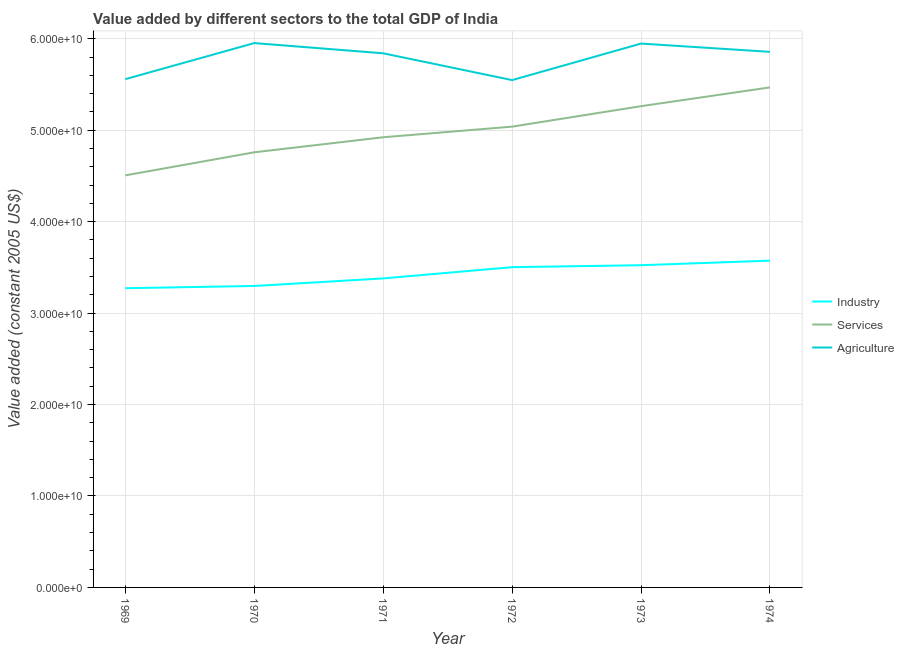Is the number of lines equal to the number of legend labels?
Offer a very short reply. Yes. What is the value added by industrial sector in 1971?
Provide a short and direct response. 3.38e+1. Across all years, what is the maximum value added by services?
Offer a terse response. 5.47e+1. Across all years, what is the minimum value added by agricultural sector?
Give a very brief answer. 5.55e+1. In which year was the value added by industrial sector minimum?
Your answer should be compact. 1969. What is the total value added by services in the graph?
Provide a short and direct response. 3.00e+11. What is the difference between the value added by agricultural sector in 1971 and that in 1972?
Provide a short and direct response. 2.93e+09. What is the difference between the value added by services in 1971 and the value added by industrial sector in 1970?
Offer a very short reply. 1.63e+1. What is the average value added by agricultural sector per year?
Your response must be concise. 5.78e+1. In the year 1971, what is the difference between the value added by agricultural sector and value added by services?
Give a very brief answer. 9.18e+09. In how many years, is the value added by services greater than 20000000000 US$?
Your response must be concise. 6. What is the ratio of the value added by industrial sector in 1969 to that in 1972?
Provide a succinct answer. 0.93. Is the difference between the value added by industrial sector in 1972 and 1974 greater than the difference between the value added by services in 1972 and 1974?
Offer a very short reply. Yes. What is the difference between the highest and the second highest value added by industrial sector?
Provide a succinct answer. 4.98e+08. What is the difference between the highest and the lowest value added by agricultural sector?
Your answer should be compact. 4.05e+09. In how many years, is the value added by agricultural sector greater than the average value added by agricultural sector taken over all years?
Make the answer very short. 4. Is the value added by industrial sector strictly less than the value added by services over the years?
Your response must be concise. Yes. How many lines are there?
Keep it short and to the point. 3. How many years are there in the graph?
Offer a terse response. 6. Are the values on the major ticks of Y-axis written in scientific E-notation?
Give a very brief answer. Yes. Does the graph contain any zero values?
Provide a succinct answer. No. How many legend labels are there?
Make the answer very short. 3. How are the legend labels stacked?
Make the answer very short. Vertical. What is the title of the graph?
Make the answer very short. Value added by different sectors to the total GDP of India. Does "Neonatal" appear as one of the legend labels in the graph?
Give a very brief answer. No. What is the label or title of the Y-axis?
Offer a terse response. Value added (constant 2005 US$). What is the Value added (constant 2005 US$) of Industry in 1969?
Your response must be concise. 3.27e+1. What is the Value added (constant 2005 US$) of Services in 1969?
Provide a short and direct response. 4.51e+1. What is the Value added (constant 2005 US$) in Agriculture in 1969?
Offer a terse response. 5.56e+1. What is the Value added (constant 2005 US$) of Industry in 1970?
Your answer should be compact. 3.30e+1. What is the Value added (constant 2005 US$) in Services in 1970?
Offer a very short reply. 4.76e+1. What is the Value added (constant 2005 US$) in Agriculture in 1970?
Offer a terse response. 5.95e+1. What is the Value added (constant 2005 US$) in Industry in 1971?
Offer a very short reply. 3.38e+1. What is the Value added (constant 2005 US$) of Services in 1971?
Provide a short and direct response. 4.92e+1. What is the Value added (constant 2005 US$) of Agriculture in 1971?
Your answer should be very brief. 5.84e+1. What is the Value added (constant 2005 US$) of Industry in 1972?
Your response must be concise. 3.50e+1. What is the Value added (constant 2005 US$) of Services in 1972?
Provide a short and direct response. 5.04e+1. What is the Value added (constant 2005 US$) in Agriculture in 1972?
Offer a terse response. 5.55e+1. What is the Value added (constant 2005 US$) in Industry in 1973?
Keep it short and to the point. 3.52e+1. What is the Value added (constant 2005 US$) in Services in 1973?
Make the answer very short. 5.26e+1. What is the Value added (constant 2005 US$) of Agriculture in 1973?
Give a very brief answer. 5.95e+1. What is the Value added (constant 2005 US$) of Industry in 1974?
Keep it short and to the point. 3.57e+1. What is the Value added (constant 2005 US$) in Services in 1974?
Your answer should be compact. 5.47e+1. What is the Value added (constant 2005 US$) of Agriculture in 1974?
Your answer should be compact. 5.86e+1. Across all years, what is the maximum Value added (constant 2005 US$) of Industry?
Provide a short and direct response. 3.57e+1. Across all years, what is the maximum Value added (constant 2005 US$) of Services?
Give a very brief answer. 5.47e+1. Across all years, what is the maximum Value added (constant 2005 US$) in Agriculture?
Give a very brief answer. 5.95e+1. Across all years, what is the minimum Value added (constant 2005 US$) of Industry?
Your answer should be compact. 3.27e+1. Across all years, what is the minimum Value added (constant 2005 US$) in Services?
Keep it short and to the point. 4.51e+1. Across all years, what is the minimum Value added (constant 2005 US$) of Agriculture?
Provide a short and direct response. 5.55e+1. What is the total Value added (constant 2005 US$) in Industry in the graph?
Your answer should be very brief. 2.06e+11. What is the total Value added (constant 2005 US$) of Services in the graph?
Offer a terse response. 3.00e+11. What is the total Value added (constant 2005 US$) of Agriculture in the graph?
Give a very brief answer. 3.47e+11. What is the difference between the Value added (constant 2005 US$) of Industry in 1969 and that in 1970?
Provide a short and direct response. -2.44e+08. What is the difference between the Value added (constant 2005 US$) in Services in 1969 and that in 1970?
Your response must be concise. -2.52e+09. What is the difference between the Value added (constant 2005 US$) of Agriculture in 1969 and that in 1970?
Make the answer very short. -3.94e+09. What is the difference between the Value added (constant 2005 US$) in Industry in 1969 and that in 1971?
Make the answer very short. -1.07e+09. What is the difference between the Value added (constant 2005 US$) in Services in 1969 and that in 1971?
Your response must be concise. -4.17e+09. What is the difference between the Value added (constant 2005 US$) in Agriculture in 1969 and that in 1971?
Your response must be concise. -2.83e+09. What is the difference between the Value added (constant 2005 US$) in Industry in 1969 and that in 1972?
Your response must be concise. -2.30e+09. What is the difference between the Value added (constant 2005 US$) of Services in 1969 and that in 1972?
Give a very brief answer. -5.33e+09. What is the difference between the Value added (constant 2005 US$) of Agriculture in 1969 and that in 1972?
Make the answer very short. 1.07e+08. What is the difference between the Value added (constant 2005 US$) of Industry in 1969 and that in 1973?
Offer a terse response. -2.52e+09. What is the difference between the Value added (constant 2005 US$) in Services in 1969 and that in 1973?
Give a very brief answer. -7.57e+09. What is the difference between the Value added (constant 2005 US$) in Agriculture in 1969 and that in 1973?
Keep it short and to the point. -3.89e+09. What is the difference between the Value added (constant 2005 US$) in Industry in 1969 and that in 1974?
Make the answer very short. -3.01e+09. What is the difference between the Value added (constant 2005 US$) of Services in 1969 and that in 1974?
Provide a short and direct response. -9.62e+09. What is the difference between the Value added (constant 2005 US$) of Agriculture in 1969 and that in 1974?
Your answer should be compact. -2.98e+09. What is the difference between the Value added (constant 2005 US$) in Industry in 1970 and that in 1971?
Give a very brief answer. -8.27e+08. What is the difference between the Value added (constant 2005 US$) of Services in 1970 and that in 1971?
Give a very brief answer. -1.64e+09. What is the difference between the Value added (constant 2005 US$) of Agriculture in 1970 and that in 1971?
Make the answer very short. 1.12e+09. What is the difference between the Value added (constant 2005 US$) in Industry in 1970 and that in 1972?
Make the answer very short. -2.06e+09. What is the difference between the Value added (constant 2005 US$) of Services in 1970 and that in 1972?
Make the answer very short. -2.81e+09. What is the difference between the Value added (constant 2005 US$) of Agriculture in 1970 and that in 1972?
Offer a very short reply. 4.05e+09. What is the difference between the Value added (constant 2005 US$) of Industry in 1970 and that in 1973?
Offer a terse response. -2.27e+09. What is the difference between the Value added (constant 2005 US$) of Services in 1970 and that in 1973?
Ensure brevity in your answer.  -5.05e+09. What is the difference between the Value added (constant 2005 US$) of Agriculture in 1970 and that in 1973?
Ensure brevity in your answer.  5.33e+07. What is the difference between the Value added (constant 2005 US$) of Industry in 1970 and that in 1974?
Keep it short and to the point. -2.77e+09. What is the difference between the Value added (constant 2005 US$) of Services in 1970 and that in 1974?
Give a very brief answer. -7.10e+09. What is the difference between the Value added (constant 2005 US$) of Agriculture in 1970 and that in 1974?
Your answer should be compact. 9.59e+08. What is the difference between the Value added (constant 2005 US$) of Industry in 1971 and that in 1972?
Provide a succinct answer. -1.23e+09. What is the difference between the Value added (constant 2005 US$) of Services in 1971 and that in 1972?
Offer a terse response. -1.16e+09. What is the difference between the Value added (constant 2005 US$) of Agriculture in 1971 and that in 1972?
Your answer should be very brief. 2.93e+09. What is the difference between the Value added (constant 2005 US$) of Industry in 1971 and that in 1973?
Ensure brevity in your answer.  -1.44e+09. What is the difference between the Value added (constant 2005 US$) of Services in 1971 and that in 1973?
Provide a short and direct response. -3.40e+09. What is the difference between the Value added (constant 2005 US$) in Agriculture in 1971 and that in 1973?
Give a very brief answer. -1.06e+09. What is the difference between the Value added (constant 2005 US$) of Industry in 1971 and that in 1974?
Provide a succinct answer. -1.94e+09. What is the difference between the Value added (constant 2005 US$) of Services in 1971 and that in 1974?
Offer a terse response. -5.46e+09. What is the difference between the Value added (constant 2005 US$) of Agriculture in 1971 and that in 1974?
Provide a short and direct response. -1.58e+08. What is the difference between the Value added (constant 2005 US$) of Industry in 1972 and that in 1973?
Your answer should be very brief. -2.15e+08. What is the difference between the Value added (constant 2005 US$) in Services in 1972 and that in 1973?
Make the answer very short. -2.24e+09. What is the difference between the Value added (constant 2005 US$) of Agriculture in 1972 and that in 1973?
Provide a short and direct response. -4.00e+09. What is the difference between the Value added (constant 2005 US$) of Industry in 1972 and that in 1974?
Offer a terse response. -7.13e+08. What is the difference between the Value added (constant 2005 US$) of Services in 1972 and that in 1974?
Provide a succinct answer. -4.29e+09. What is the difference between the Value added (constant 2005 US$) in Agriculture in 1972 and that in 1974?
Your response must be concise. -3.09e+09. What is the difference between the Value added (constant 2005 US$) in Industry in 1973 and that in 1974?
Give a very brief answer. -4.98e+08. What is the difference between the Value added (constant 2005 US$) in Services in 1973 and that in 1974?
Your answer should be very brief. -2.06e+09. What is the difference between the Value added (constant 2005 US$) in Agriculture in 1973 and that in 1974?
Your answer should be compact. 9.06e+08. What is the difference between the Value added (constant 2005 US$) in Industry in 1969 and the Value added (constant 2005 US$) in Services in 1970?
Provide a succinct answer. -1.49e+1. What is the difference between the Value added (constant 2005 US$) of Industry in 1969 and the Value added (constant 2005 US$) of Agriculture in 1970?
Ensure brevity in your answer.  -2.68e+1. What is the difference between the Value added (constant 2005 US$) of Services in 1969 and the Value added (constant 2005 US$) of Agriculture in 1970?
Your answer should be compact. -1.45e+1. What is the difference between the Value added (constant 2005 US$) of Industry in 1969 and the Value added (constant 2005 US$) of Services in 1971?
Keep it short and to the point. -1.65e+1. What is the difference between the Value added (constant 2005 US$) of Industry in 1969 and the Value added (constant 2005 US$) of Agriculture in 1971?
Make the answer very short. -2.57e+1. What is the difference between the Value added (constant 2005 US$) of Services in 1969 and the Value added (constant 2005 US$) of Agriculture in 1971?
Your response must be concise. -1.34e+1. What is the difference between the Value added (constant 2005 US$) in Industry in 1969 and the Value added (constant 2005 US$) in Services in 1972?
Your answer should be very brief. -1.77e+1. What is the difference between the Value added (constant 2005 US$) of Industry in 1969 and the Value added (constant 2005 US$) of Agriculture in 1972?
Offer a terse response. -2.28e+1. What is the difference between the Value added (constant 2005 US$) of Services in 1969 and the Value added (constant 2005 US$) of Agriculture in 1972?
Your response must be concise. -1.04e+1. What is the difference between the Value added (constant 2005 US$) in Industry in 1969 and the Value added (constant 2005 US$) in Services in 1973?
Provide a short and direct response. -1.99e+1. What is the difference between the Value added (constant 2005 US$) of Industry in 1969 and the Value added (constant 2005 US$) of Agriculture in 1973?
Keep it short and to the point. -2.68e+1. What is the difference between the Value added (constant 2005 US$) in Services in 1969 and the Value added (constant 2005 US$) in Agriculture in 1973?
Keep it short and to the point. -1.44e+1. What is the difference between the Value added (constant 2005 US$) of Industry in 1969 and the Value added (constant 2005 US$) of Services in 1974?
Offer a terse response. -2.20e+1. What is the difference between the Value added (constant 2005 US$) of Industry in 1969 and the Value added (constant 2005 US$) of Agriculture in 1974?
Provide a succinct answer. -2.59e+1. What is the difference between the Value added (constant 2005 US$) in Services in 1969 and the Value added (constant 2005 US$) in Agriculture in 1974?
Provide a succinct answer. -1.35e+1. What is the difference between the Value added (constant 2005 US$) of Industry in 1970 and the Value added (constant 2005 US$) of Services in 1971?
Give a very brief answer. -1.63e+1. What is the difference between the Value added (constant 2005 US$) in Industry in 1970 and the Value added (constant 2005 US$) in Agriculture in 1971?
Ensure brevity in your answer.  -2.54e+1. What is the difference between the Value added (constant 2005 US$) in Services in 1970 and the Value added (constant 2005 US$) in Agriculture in 1971?
Ensure brevity in your answer.  -1.08e+1. What is the difference between the Value added (constant 2005 US$) in Industry in 1970 and the Value added (constant 2005 US$) in Services in 1972?
Offer a very short reply. -1.74e+1. What is the difference between the Value added (constant 2005 US$) of Industry in 1970 and the Value added (constant 2005 US$) of Agriculture in 1972?
Your response must be concise. -2.25e+1. What is the difference between the Value added (constant 2005 US$) in Services in 1970 and the Value added (constant 2005 US$) in Agriculture in 1972?
Offer a terse response. -7.90e+09. What is the difference between the Value added (constant 2005 US$) in Industry in 1970 and the Value added (constant 2005 US$) in Services in 1973?
Your answer should be compact. -1.97e+1. What is the difference between the Value added (constant 2005 US$) in Industry in 1970 and the Value added (constant 2005 US$) in Agriculture in 1973?
Your answer should be compact. -2.65e+1. What is the difference between the Value added (constant 2005 US$) in Services in 1970 and the Value added (constant 2005 US$) in Agriculture in 1973?
Offer a very short reply. -1.19e+1. What is the difference between the Value added (constant 2005 US$) in Industry in 1970 and the Value added (constant 2005 US$) in Services in 1974?
Keep it short and to the point. -2.17e+1. What is the difference between the Value added (constant 2005 US$) of Industry in 1970 and the Value added (constant 2005 US$) of Agriculture in 1974?
Your response must be concise. -2.56e+1. What is the difference between the Value added (constant 2005 US$) in Services in 1970 and the Value added (constant 2005 US$) in Agriculture in 1974?
Keep it short and to the point. -1.10e+1. What is the difference between the Value added (constant 2005 US$) of Industry in 1971 and the Value added (constant 2005 US$) of Services in 1972?
Your answer should be very brief. -1.66e+1. What is the difference between the Value added (constant 2005 US$) in Industry in 1971 and the Value added (constant 2005 US$) in Agriculture in 1972?
Your response must be concise. -2.17e+1. What is the difference between the Value added (constant 2005 US$) of Services in 1971 and the Value added (constant 2005 US$) of Agriculture in 1972?
Offer a very short reply. -6.25e+09. What is the difference between the Value added (constant 2005 US$) of Industry in 1971 and the Value added (constant 2005 US$) of Services in 1973?
Ensure brevity in your answer.  -1.88e+1. What is the difference between the Value added (constant 2005 US$) in Industry in 1971 and the Value added (constant 2005 US$) in Agriculture in 1973?
Provide a short and direct response. -2.57e+1. What is the difference between the Value added (constant 2005 US$) in Services in 1971 and the Value added (constant 2005 US$) in Agriculture in 1973?
Ensure brevity in your answer.  -1.02e+1. What is the difference between the Value added (constant 2005 US$) of Industry in 1971 and the Value added (constant 2005 US$) of Services in 1974?
Keep it short and to the point. -2.09e+1. What is the difference between the Value added (constant 2005 US$) in Industry in 1971 and the Value added (constant 2005 US$) in Agriculture in 1974?
Ensure brevity in your answer.  -2.48e+1. What is the difference between the Value added (constant 2005 US$) in Services in 1971 and the Value added (constant 2005 US$) in Agriculture in 1974?
Make the answer very short. -9.34e+09. What is the difference between the Value added (constant 2005 US$) of Industry in 1972 and the Value added (constant 2005 US$) of Services in 1973?
Offer a terse response. -1.76e+1. What is the difference between the Value added (constant 2005 US$) of Industry in 1972 and the Value added (constant 2005 US$) of Agriculture in 1973?
Provide a succinct answer. -2.45e+1. What is the difference between the Value added (constant 2005 US$) in Services in 1972 and the Value added (constant 2005 US$) in Agriculture in 1973?
Your answer should be compact. -9.08e+09. What is the difference between the Value added (constant 2005 US$) of Industry in 1972 and the Value added (constant 2005 US$) of Services in 1974?
Your answer should be compact. -1.97e+1. What is the difference between the Value added (constant 2005 US$) of Industry in 1972 and the Value added (constant 2005 US$) of Agriculture in 1974?
Provide a succinct answer. -2.35e+1. What is the difference between the Value added (constant 2005 US$) in Services in 1972 and the Value added (constant 2005 US$) in Agriculture in 1974?
Your answer should be very brief. -8.18e+09. What is the difference between the Value added (constant 2005 US$) in Industry in 1973 and the Value added (constant 2005 US$) in Services in 1974?
Provide a short and direct response. -1.94e+1. What is the difference between the Value added (constant 2005 US$) in Industry in 1973 and the Value added (constant 2005 US$) in Agriculture in 1974?
Your response must be concise. -2.33e+1. What is the difference between the Value added (constant 2005 US$) of Services in 1973 and the Value added (constant 2005 US$) of Agriculture in 1974?
Your answer should be very brief. -5.94e+09. What is the average Value added (constant 2005 US$) in Industry per year?
Offer a very short reply. 3.43e+1. What is the average Value added (constant 2005 US$) in Services per year?
Ensure brevity in your answer.  4.99e+1. What is the average Value added (constant 2005 US$) of Agriculture per year?
Ensure brevity in your answer.  5.78e+1. In the year 1969, what is the difference between the Value added (constant 2005 US$) of Industry and Value added (constant 2005 US$) of Services?
Give a very brief answer. -1.23e+1. In the year 1969, what is the difference between the Value added (constant 2005 US$) in Industry and Value added (constant 2005 US$) in Agriculture?
Keep it short and to the point. -2.29e+1. In the year 1969, what is the difference between the Value added (constant 2005 US$) of Services and Value added (constant 2005 US$) of Agriculture?
Keep it short and to the point. -1.05e+1. In the year 1970, what is the difference between the Value added (constant 2005 US$) in Industry and Value added (constant 2005 US$) in Services?
Make the answer very short. -1.46e+1. In the year 1970, what is the difference between the Value added (constant 2005 US$) in Industry and Value added (constant 2005 US$) in Agriculture?
Make the answer very short. -2.66e+1. In the year 1970, what is the difference between the Value added (constant 2005 US$) of Services and Value added (constant 2005 US$) of Agriculture?
Offer a very short reply. -1.19e+1. In the year 1971, what is the difference between the Value added (constant 2005 US$) in Industry and Value added (constant 2005 US$) in Services?
Keep it short and to the point. -1.54e+1. In the year 1971, what is the difference between the Value added (constant 2005 US$) in Industry and Value added (constant 2005 US$) in Agriculture?
Make the answer very short. -2.46e+1. In the year 1971, what is the difference between the Value added (constant 2005 US$) of Services and Value added (constant 2005 US$) of Agriculture?
Your answer should be compact. -9.18e+09. In the year 1972, what is the difference between the Value added (constant 2005 US$) of Industry and Value added (constant 2005 US$) of Services?
Provide a succinct answer. -1.54e+1. In the year 1972, what is the difference between the Value added (constant 2005 US$) of Industry and Value added (constant 2005 US$) of Agriculture?
Provide a short and direct response. -2.05e+1. In the year 1972, what is the difference between the Value added (constant 2005 US$) of Services and Value added (constant 2005 US$) of Agriculture?
Provide a short and direct response. -5.09e+09. In the year 1973, what is the difference between the Value added (constant 2005 US$) of Industry and Value added (constant 2005 US$) of Services?
Keep it short and to the point. -1.74e+1. In the year 1973, what is the difference between the Value added (constant 2005 US$) in Industry and Value added (constant 2005 US$) in Agriculture?
Offer a very short reply. -2.42e+1. In the year 1973, what is the difference between the Value added (constant 2005 US$) of Services and Value added (constant 2005 US$) of Agriculture?
Ensure brevity in your answer.  -6.85e+09. In the year 1974, what is the difference between the Value added (constant 2005 US$) of Industry and Value added (constant 2005 US$) of Services?
Provide a short and direct response. -1.90e+1. In the year 1974, what is the difference between the Value added (constant 2005 US$) in Industry and Value added (constant 2005 US$) in Agriculture?
Offer a terse response. -2.28e+1. In the year 1974, what is the difference between the Value added (constant 2005 US$) of Services and Value added (constant 2005 US$) of Agriculture?
Your answer should be very brief. -3.89e+09. What is the ratio of the Value added (constant 2005 US$) of Industry in 1969 to that in 1970?
Offer a terse response. 0.99. What is the ratio of the Value added (constant 2005 US$) in Services in 1969 to that in 1970?
Your answer should be compact. 0.95. What is the ratio of the Value added (constant 2005 US$) in Agriculture in 1969 to that in 1970?
Give a very brief answer. 0.93. What is the ratio of the Value added (constant 2005 US$) of Industry in 1969 to that in 1971?
Offer a very short reply. 0.97. What is the ratio of the Value added (constant 2005 US$) in Services in 1969 to that in 1971?
Your answer should be compact. 0.92. What is the ratio of the Value added (constant 2005 US$) in Agriculture in 1969 to that in 1971?
Your answer should be very brief. 0.95. What is the ratio of the Value added (constant 2005 US$) of Industry in 1969 to that in 1972?
Make the answer very short. 0.93. What is the ratio of the Value added (constant 2005 US$) in Services in 1969 to that in 1972?
Keep it short and to the point. 0.89. What is the ratio of the Value added (constant 2005 US$) of Services in 1969 to that in 1973?
Provide a short and direct response. 0.86. What is the ratio of the Value added (constant 2005 US$) of Agriculture in 1969 to that in 1973?
Offer a terse response. 0.93. What is the ratio of the Value added (constant 2005 US$) of Industry in 1969 to that in 1974?
Offer a very short reply. 0.92. What is the ratio of the Value added (constant 2005 US$) in Services in 1969 to that in 1974?
Provide a short and direct response. 0.82. What is the ratio of the Value added (constant 2005 US$) in Agriculture in 1969 to that in 1974?
Keep it short and to the point. 0.95. What is the ratio of the Value added (constant 2005 US$) in Industry in 1970 to that in 1971?
Your response must be concise. 0.98. What is the ratio of the Value added (constant 2005 US$) of Services in 1970 to that in 1971?
Your answer should be very brief. 0.97. What is the ratio of the Value added (constant 2005 US$) of Agriculture in 1970 to that in 1971?
Offer a terse response. 1.02. What is the ratio of the Value added (constant 2005 US$) of Industry in 1970 to that in 1972?
Your answer should be very brief. 0.94. What is the ratio of the Value added (constant 2005 US$) of Services in 1970 to that in 1972?
Your response must be concise. 0.94. What is the ratio of the Value added (constant 2005 US$) of Agriculture in 1970 to that in 1972?
Your response must be concise. 1.07. What is the ratio of the Value added (constant 2005 US$) in Industry in 1970 to that in 1973?
Keep it short and to the point. 0.94. What is the ratio of the Value added (constant 2005 US$) in Services in 1970 to that in 1973?
Offer a very short reply. 0.9. What is the ratio of the Value added (constant 2005 US$) in Industry in 1970 to that in 1974?
Ensure brevity in your answer.  0.92. What is the ratio of the Value added (constant 2005 US$) in Services in 1970 to that in 1974?
Make the answer very short. 0.87. What is the ratio of the Value added (constant 2005 US$) in Agriculture in 1970 to that in 1974?
Your response must be concise. 1.02. What is the ratio of the Value added (constant 2005 US$) in Industry in 1971 to that in 1972?
Give a very brief answer. 0.96. What is the ratio of the Value added (constant 2005 US$) of Services in 1971 to that in 1972?
Give a very brief answer. 0.98. What is the ratio of the Value added (constant 2005 US$) of Agriculture in 1971 to that in 1972?
Make the answer very short. 1.05. What is the ratio of the Value added (constant 2005 US$) in Services in 1971 to that in 1973?
Your answer should be very brief. 0.94. What is the ratio of the Value added (constant 2005 US$) of Agriculture in 1971 to that in 1973?
Your answer should be compact. 0.98. What is the ratio of the Value added (constant 2005 US$) in Industry in 1971 to that in 1974?
Make the answer very short. 0.95. What is the ratio of the Value added (constant 2005 US$) of Services in 1971 to that in 1974?
Give a very brief answer. 0.9. What is the ratio of the Value added (constant 2005 US$) in Industry in 1972 to that in 1973?
Offer a terse response. 0.99. What is the ratio of the Value added (constant 2005 US$) of Services in 1972 to that in 1973?
Provide a succinct answer. 0.96. What is the ratio of the Value added (constant 2005 US$) of Agriculture in 1972 to that in 1973?
Give a very brief answer. 0.93. What is the ratio of the Value added (constant 2005 US$) in Industry in 1972 to that in 1974?
Make the answer very short. 0.98. What is the ratio of the Value added (constant 2005 US$) in Services in 1972 to that in 1974?
Make the answer very short. 0.92. What is the ratio of the Value added (constant 2005 US$) in Agriculture in 1972 to that in 1974?
Provide a succinct answer. 0.95. What is the ratio of the Value added (constant 2005 US$) of Industry in 1973 to that in 1974?
Make the answer very short. 0.99. What is the ratio of the Value added (constant 2005 US$) of Services in 1973 to that in 1974?
Make the answer very short. 0.96. What is the ratio of the Value added (constant 2005 US$) of Agriculture in 1973 to that in 1974?
Offer a terse response. 1.02. What is the difference between the highest and the second highest Value added (constant 2005 US$) in Industry?
Provide a succinct answer. 4.98e+08. What is the difference between the highest and the second highest Value added (constant 2005 US$) in Services?
Your response must be concise. 2.06e+09. What is the difference between the highest and the second highest Value added (constant 2005 US$) in Agriculture?
Ensure brevity in your answer.  5.33e+07. What is the difference between the highest and the lowest Value added (constant 2005 US$) in Industry?
Your answer should be very brief. 3.01e+09. What is the difference between the highest and the lowest Value added (constant 2005 US$) of Services?
Make the answer very short. 9.62e+09. What is the difference between the highest and the lowest Value added (constant 2005 US$) in Agriculture?
Keep it short and to the point. 4.05e+09. 